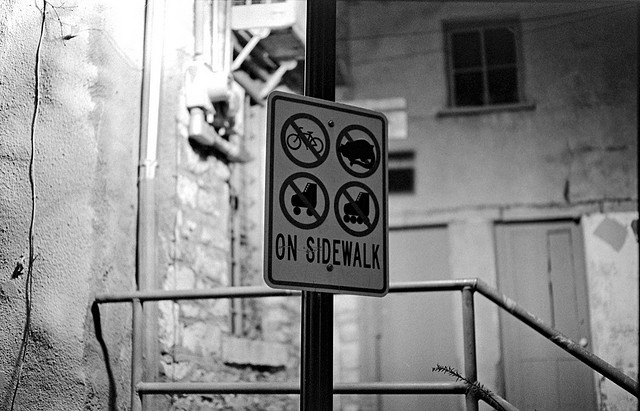Describe the objects in this image and their specific colors. I can see various objects in this image with different colors. 